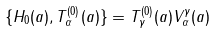<formula> <loc_0><loc_0><loc_500><loc_500>\{ H _ { 0 } ( a ) , T ^ { ( 0 ) } _ { \alpha } ( a ) \} = T ^ { ( 0 ) } _ { \gamma } ( a ) V ^ { \gamma } _ { \alpha } ( a )</formula> 